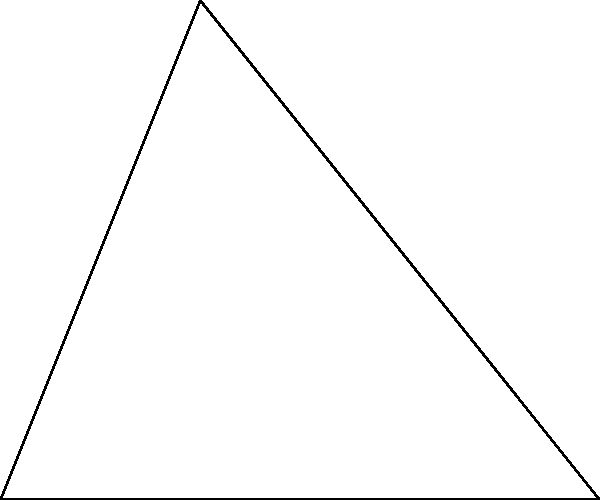Chief Adebayo is involved in a land dispute over a triangular plot. The surveyor has measured two sides of the plot: one side is 6 km long, and another is 5 km long. The angle between these sides is 60°. What is the area of the disputed land in square kilometers? To solve this problem, we'll use the formula for the area of a triangle given two sides and the included angle:

$$A = \frac{1}{2} ab \sin C$$

Where:
$A$ is the area of the triangle
$a$ and $b$ are the lengths of the two known sides
$C$ is the angle between these sides

Step 1: Identify the given information
$a = 6$ km
$b = 5$ km
$C = 60°$

Step 2: Substitute the values into the formula
$$A = \frac{1}{2} \cdot 6 \cdot 5 \cdot \sin 60°$$

Step 3: Calculate $\sin 60°$
$\sin 60° = \frac{\sqrt{3}}{2}$

Step 4: Substitute this value and calculate
$$A = \frac{1}{2} \cdot 6 \cdot 5 \cdot \frac{\sqrt{3}}{2}$$
$$A = \frac{15\sqrt{3}}{2}$$

Step 5: Simplify and calculate the final result
$$A = \frac{15 \cdot 1.732}{2} \approx 12.99 \text{ km}^2$$

Therefore, the area of the disputed land is approximately 12.99 square kilometers.
Answer: $12.99 \text{ km}^2$ 